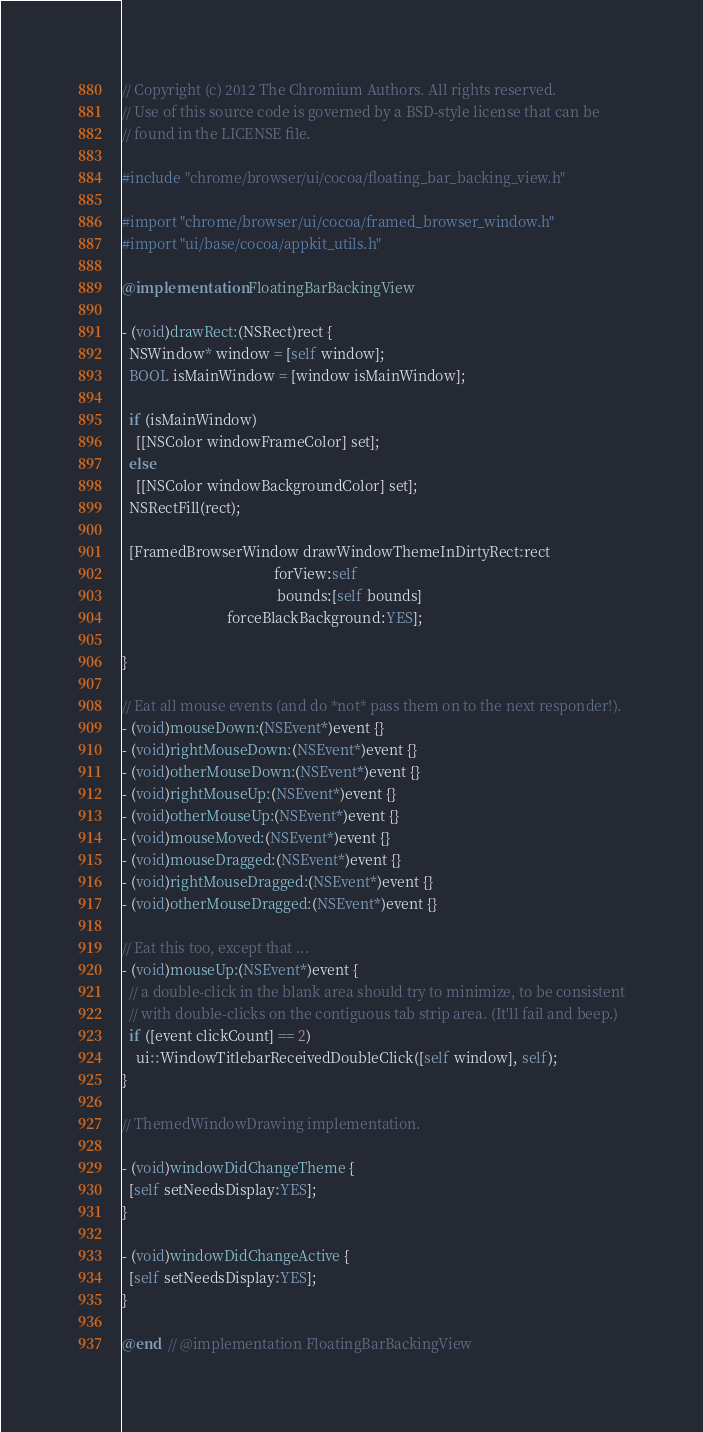<code> <loc_0><loc_0><loc_500><loc_500><_ObjectiveC_>// Copyright (c) 2012 The Chromium Authors. All rights reserved.
// Use of this source code is governed by a BSD-style license that can be
// found in the LICENSE file.

#include "chrome/browser/ui/cocoa/floating_bar_backing_view.h"

#import "chrome/browser/ui/cocoa/framed_browser_window.h"
#import "ui/base/cocoa/appkit_utils.h"

@implementation FloatingBarBackingView

- (void)drawRect:(NSRect)rect {
  NSWindow* window = [self window];
  BOOL isMainWindow = [window isMainWindow];

  if (isMainWindow)
    [[NSColor windowFrameColor] set];
  else
    [[NSColor windowBackgroundColor] set];
  NSRectFill(rect);

  [FramedBrowserWindow drawWindowThemeInDirtyRect:rect
                                          forView:self
                                           bounds:[self bounds]
                             forceBlackBackground:YES];

}

// Eat all mouse events (and do *not* pass them on to the next responder!).
- (void)mouseDown:(NSEvent*)event {}
- (void)rightMouseDown:(NSEvent*)event {}
- (void)otherMouseDown:(NSEvent*)event {}
- (void)rightMouseUp:(NSEvent*)event {}
- (void)otherMouseUp:(NSEvent*)event {}
- (void)mouseMoved:(NSEvent*)event {}
- (void)mouseDragged:(NSEvent*)event {}
- (void)rightMouseDragged:(NSEvent*)event {}
- (void)otherMouseDragged:(NSEvent*)event {}

// Eat this too, except that ...
- (void)mouseUp:(NSEvent*)event {
  // a double-click in the blank area should try to minimize, to be consistent
  // with double-clicks on the contiguous tab strip area. (It'll fail and beep.)
  if ([event clickCount] == 2)
    ui::WindowTitlebarReceivedDoubleClick([self window], self);
}

// ThemedWindowDrawing implementation.

- (void)windowDidChangeTheme {
  [self setNeedsDisplay:YES];
}

- (void)windowDidChangeActive {
  [self setNeedsDisplay:YES];
}

@end  // @implementation FloatingBarBackingView
</code> 